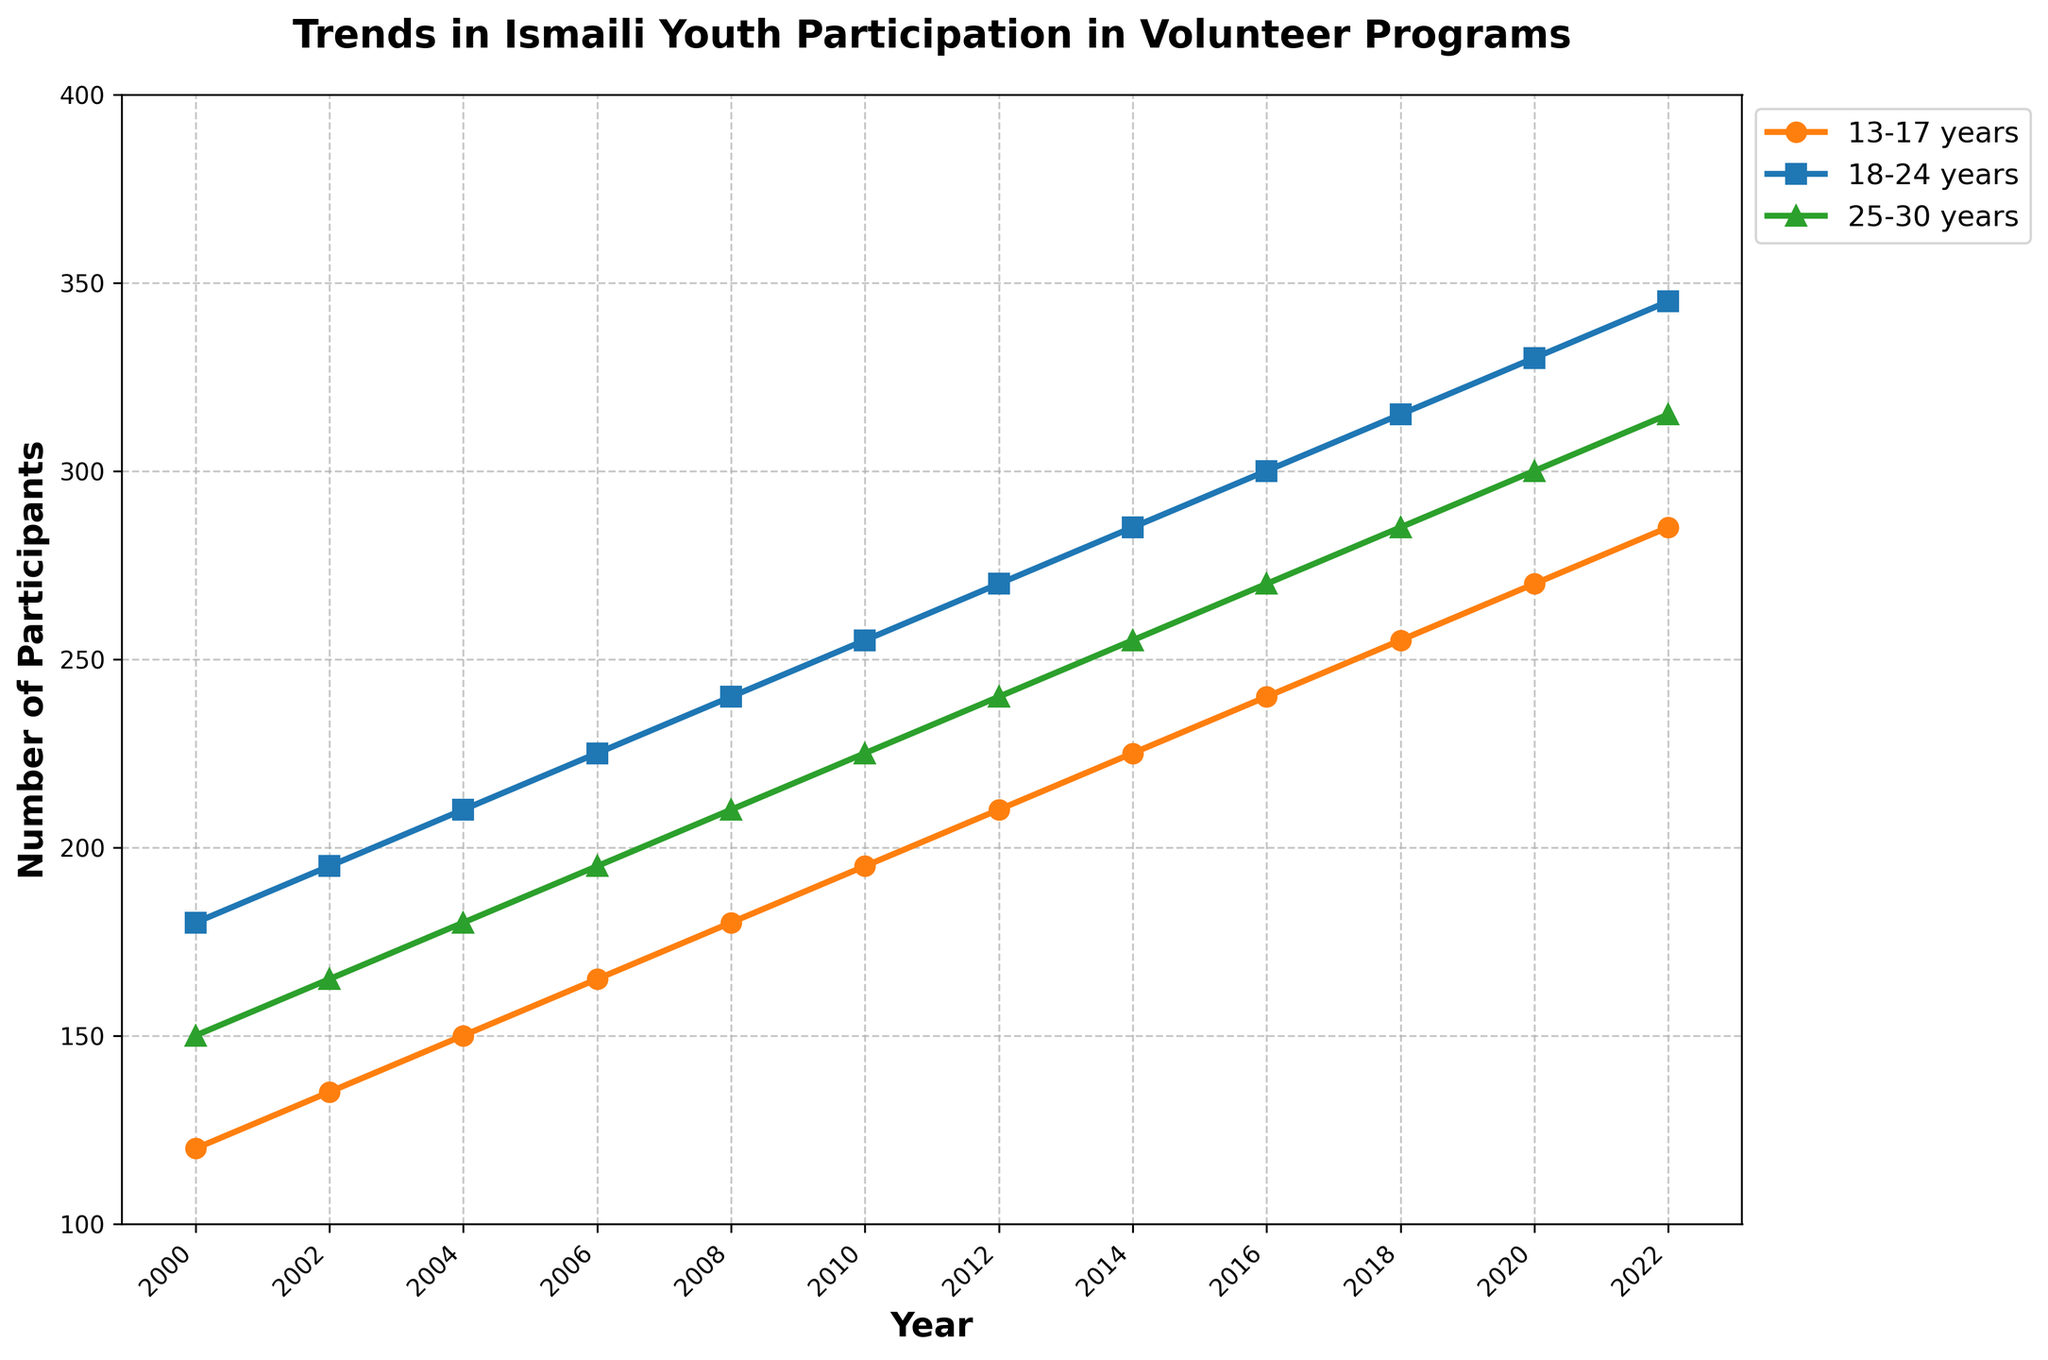Which age group had the highest number of participants in 2022? Looking at the data for 2022, the age groups '13-17 years', '18-24 years', and '25-30 years' had 285, 345, and 315 participants, respectively. The highest value is 345, which corresponds to the '18-24 years' age group.
Answer: '18-24 years' What was the total number of participants across all age groups in 2010? Add the number of participants in each age group for the year 2010: 195 (13-17 years) + 255 (18-24 years) + 225 (25-30 years). This results in 675 participants.
Answer: 675 In which years did the '25-30 years' group have exactly 180 participants? From the data provided, the '25-30 years' group had 180 participants in the year 2004.
Answer: 2004 How did the number of participants in the '13-17 years' group change from 2000 to 2022? Subtract the number of participants in the '13-17 years' group in 2000 from the number in 2022: 285 (2022) - 120 (2000). The result is an increase of 165 participants.
Answer: Increased by 165 Which age group showed the most consistent increase in participants from 2000 to 2022? To find the age group with the most consistent increase, we look for linear growth without large fluctuations in the data points. All age groups show consistent increases, but the trend in '18-24 years' appears most linear.
Answer: '18-24 years' What is the difference in the number of participants between the '13-17 years' group and the '25-30 years' group in 2018? Subtract the number of participants in the '25-30 years' group from the '13-17 years' group in 2018: 255 (13-17 years) - 285 (25-30 years). The difference is -30.
Answer: -30 What was the average number of participants in the '18-24 years' group from 2000 to 2022? Sum the number of participants in the '18-24 years' group from 2000 to 2022 and then divide by the number of years (12): (180 + 195 + 210 + 225 + 240 + 255 + 270 + 285 + 300 + 315 + 330 + 345)/12. The sum is 3,450, so the average is 3,450 / 12.
Answer: 287.5 Between which two consecutive years was the largest increase in participation observed in the '13-17 years' group? The largest increase is found by calculating the differences between consecutive years and identifying the maximum: 
2002 - 2000: 135 - 120 = 15 
2004 - 2002: 150 - 135 = 15 
2006 - 2004: 165 - 150 = 15 
2008 - 2006: 180 - 165 = 15 
2010 - 2008: 195 - 180 = 15 
2012 - 2010: 210 - 195 = 15 
2014 - 2012: 225 - 210 = 15 
2016 - 2014: 240 - 225 = 15 
2018 - 2016: 255 - 240 = 15 
2020 - 2018: 270 - 255 = 15 
2022 - 2020: 285 - 270 = 15 
Therefore, since all increases are uniform, no single pair of consecutive years has a larger increase.
Answer: Each consecutive pair (uniform increase of 15 participants) Does the '25-30 years' age group always have more participants than the '13-17 years' age group throughout the years 2000 to 2022? Compare the number of participants in both age groups year by year: 2000 (150 > 120), 2002 (165 > 135), 2004 (180 > 150), 2006 (195 > 165), 2008 (210 > 180), 2010 (225 > 195), 2012 (240 > 210), 2014 (255 > 225), 2016 (270 > 240), 2018 (285 > 255), 2020 (300 > 270), 2022 (315 > 285). The '25-30 years' group always has more participants.
Answer: Yes Which year had the lowest total participation in volunteer programs across all age groups? Sum the numbers for each year and find the minimum total: 
2000: 120 + 180 + 150 = 450
2002: 135 + 195 + 165 = 495
2004: 150 + 210 + 180 = 540
2006: 165 + 225 + 195 = 585
2008: 180 + 240 + 210 = 630
2010: 195 + 255 + 225 = 675
2012: 210 + 270 + 240 = 720
2014: 225 + 285 + 255 = 765
2016: 240 + 300 + 270 = 810
2018: 255 + 315 + 285 = 855
2020: 270 + 330 + 300 = 900
2022: 285 + 345 + 315 = 945
The lowest total participation was in 2000, with a total of 450 participants.
Answer: 2000 